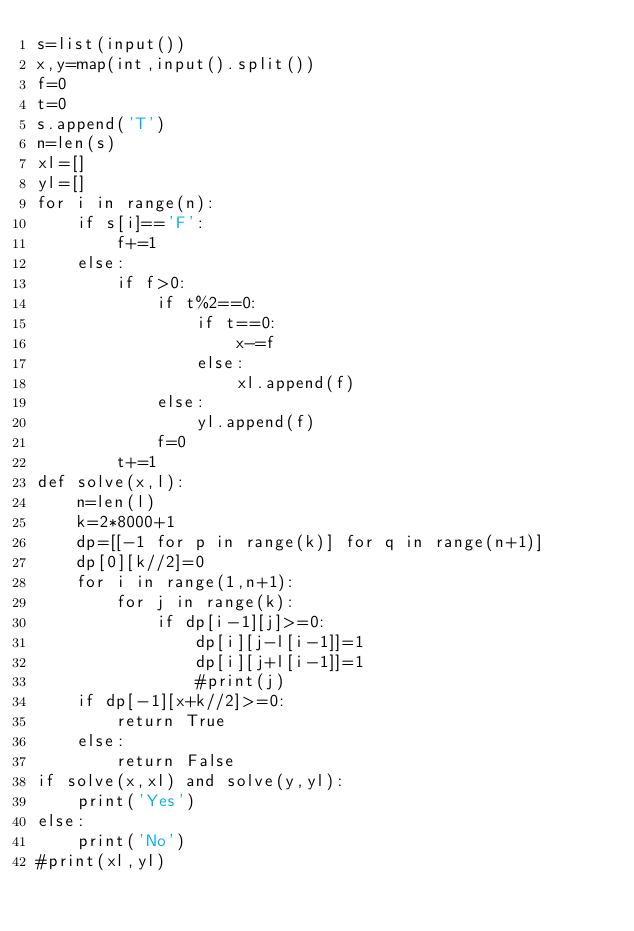<code> <loc_0><loc_0><loc_500><loc_500><_Python_>s=list(input())
x,y=map(int,input().split())
f=0
t=0
s.append('T')
n=len(s)
xl=[]
yl=[]
for i in range(n):
    if s[i]=='F':
        f+=1
    else:
        if f>0:
            if t%2==0:
                if t==0:
                    x-=f
                else:
                    xl.append(f)
            else:
                yl.append(f)
            f=0
        t+=1
def solve(x,l):
    n=len(l)
    k=2*8000+1
    dp=[[-1 for p in range(k)] for q in range(n+1)]
    dp[0][k//2]=0
    for i in range(1,n+1):
        for j in range(k):
            if dp[i-1][j]>=0:
                dp[i][j-l[i-1]]=1
                dp[i][j+l[i-1]]=1
                #print(j)
    if dp[-1][x+k//2]>=0:
        return True
    else:
        return False
if solve(x,xl) and solve(y,yl):
    print('Yes')
else:
    print('No')
#print(xl,yl)
</code> 